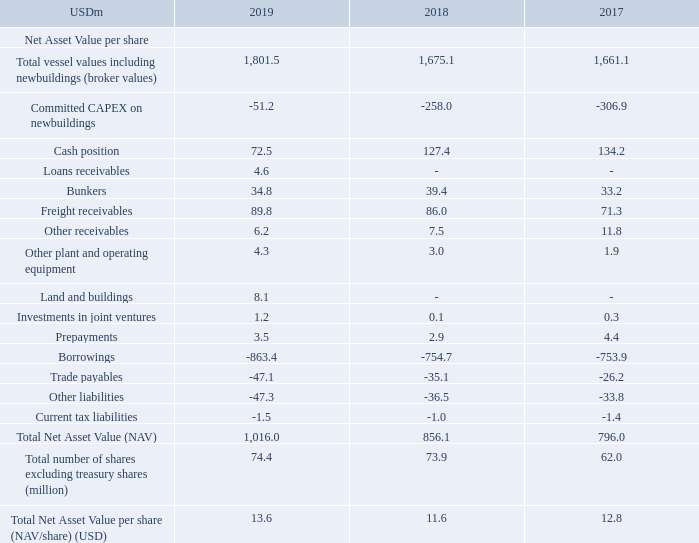Net Asset Value per share (NAV/share):
TORM believes that the NAV/share is a relevant measure that Management uses to measure the overall development of the assets and liabilities per share. Such measure may not be comparable to similarly titled measures of other companies. NAV/share is calculated using broker values of vessels and excluding charter commitments. NAV/share is calculated as follows:
What does TORM believe that the NAV/share is a relevant measure for? Management uses to measure the overall development of the assets and liabilities per share. How is NAV/share calculated? Using broker values of vessels and excluding charter commitments. For which years is the Total Net Asset Value per share (NAV/share) calculated? 2019, 2018, 2017. In which year was the Total Net Asset Value per share (NAV/share) the largest? 13.6>12.8>11.6
Answer: 2019. What was the change in the Total Net Asset Value (NAV) in 2019 from 2018?
Answer scale should be: million. 1,016.0-856.1
Answer: 159.9. What was the percentage change in the Total Net Asset Value (NAV) in 2019 from 2018?
Answer scale should be: percent. (1,016.0-856.1)/856.1
Answer: 18.68. 